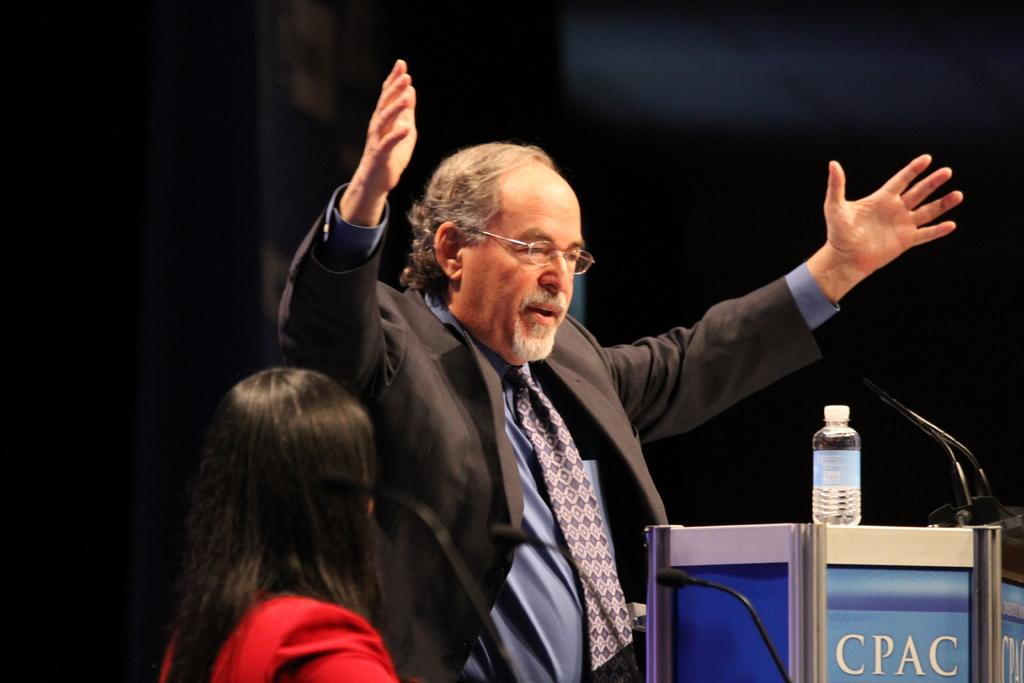<image>
Relay a brief, clear account of the picture shown. A man stands at a podium labelled CPAC and holds his arms up. 